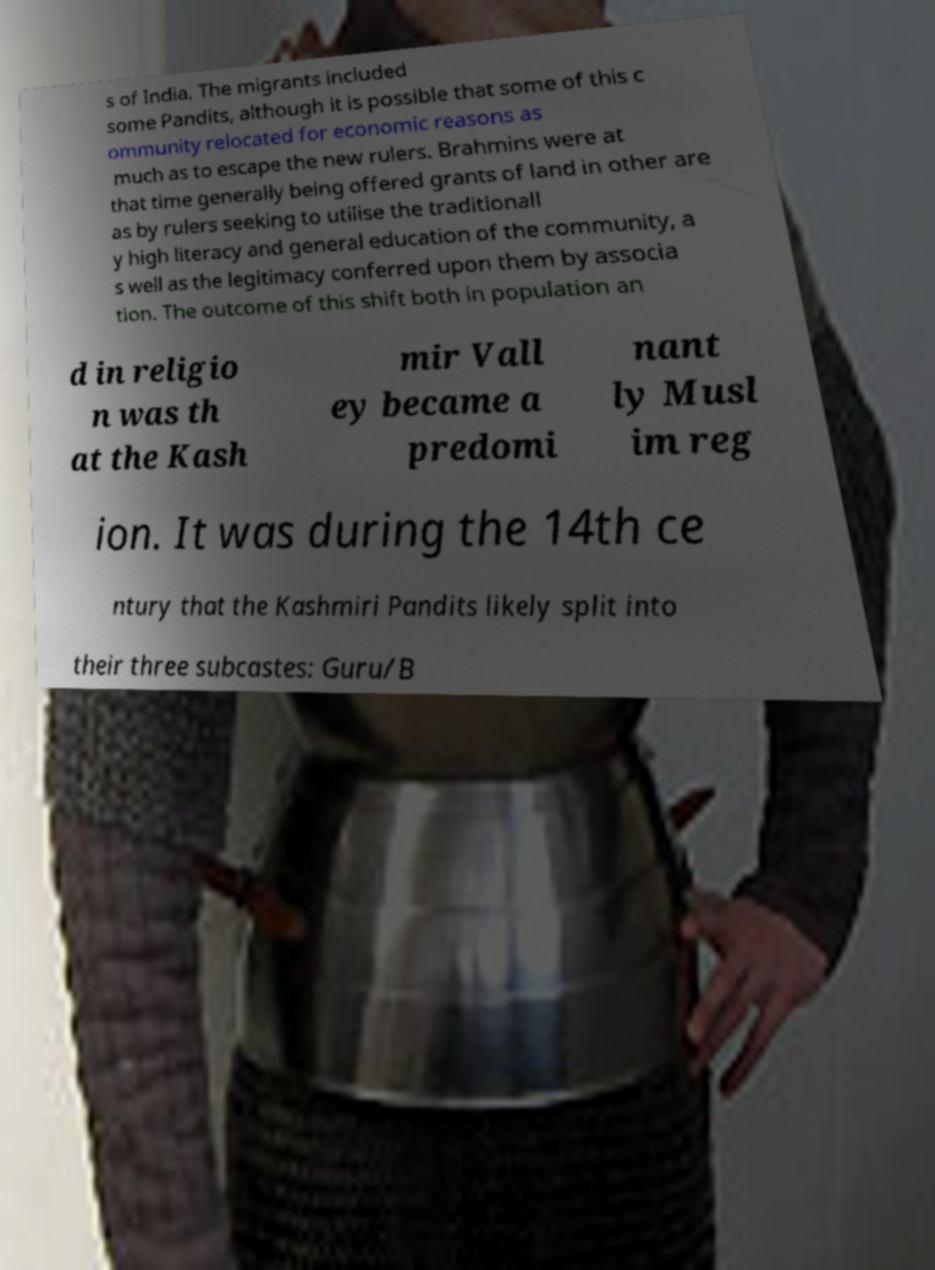What messages or text are displayed in this image? I need them in a readable, typed format. s of India. The migrants included some Pandits, although it is possible that some of this c ommunity relocated for economic reasons as much as to escape the new rulers. Brahmins were at that time generally being offered grants of land in other are as by rulers seeking to utilise the traditionall y high literacy and general education of the community, a s well as the legitimacy conferred upon them by associa tion. The outcome of this shift both in population an d in religio n was th at the Kash mir Vall ey became a predomi nant ly Musl im reg ion. It was during the 14th ce ntury that the Kashmiri Pandits likely split into their three subcastes: Guru/B 